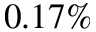Convert formula to latex. <formula><loc_0><loc_0><loc_500><loc_500>0 . 1 7 \%</formula> 